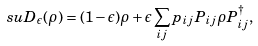Convert formula to latex. <formula><loc_0><loc_0><loc_500><loc_500>\ s u { D } _ { \epsilon } ( \rho ) = ( 1 - \epsilon ) \rho + \epsilon \sum _ { i j } p _ { i j } P _ { i j } \rho P _ { i j } ^ { \dag } ,</formula> 